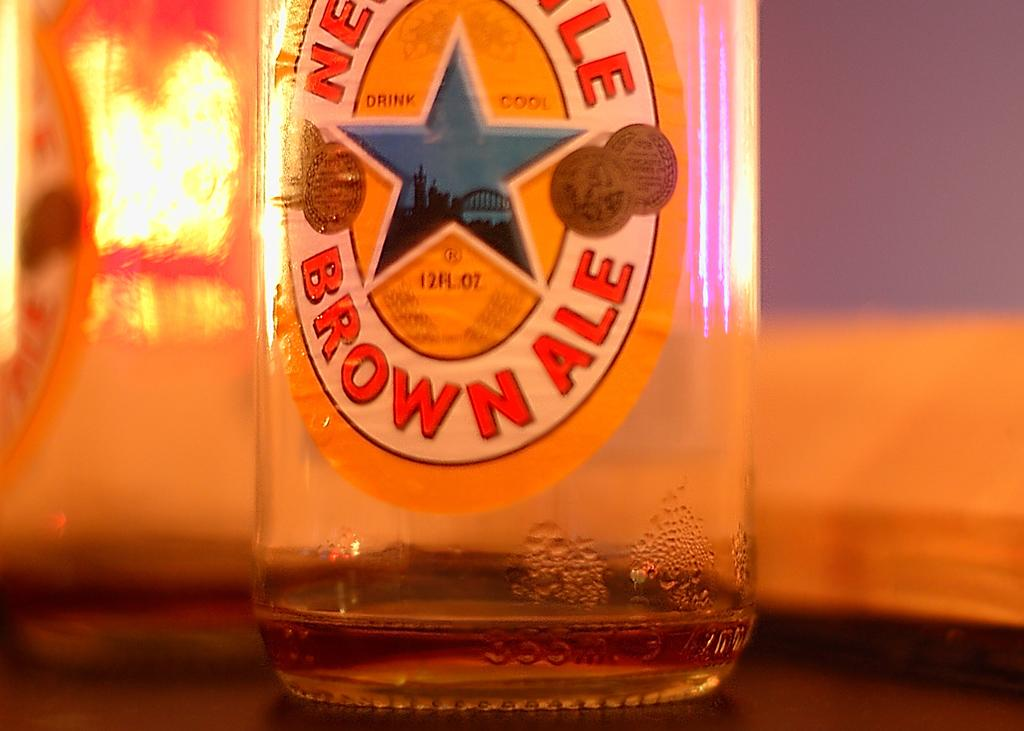<image>
Write a terse but informative summary of the picture. An empty bottle of New Castle Brown Ale. 